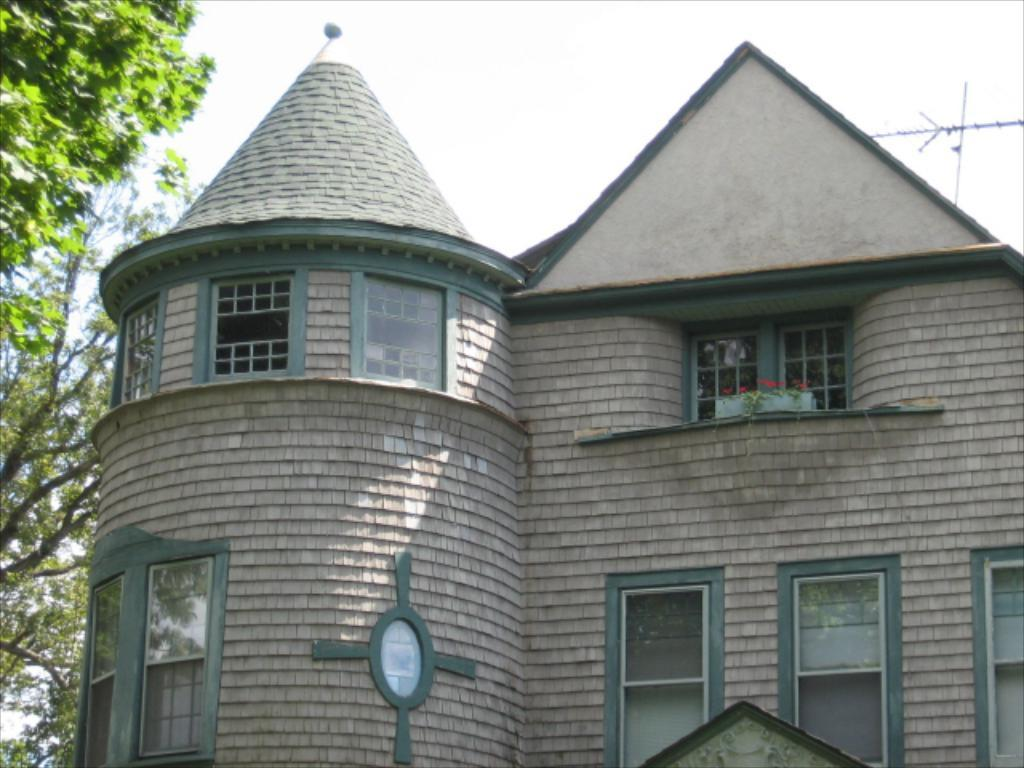What is the main subject in the center of the image? There is a building in the center of the image. What feature can be seen on the building? The building has windows. What type of vegetation is on the left side of the image? There is a tree on the left side of the image. What is visible at the top of the image? The sky is visible at the top of the image. Where is the rod used for fishing in the image? There is no rod used for fishing present in the image. What type of camera can be seen capturing the scene in the image? There is no camera visible in the image. 